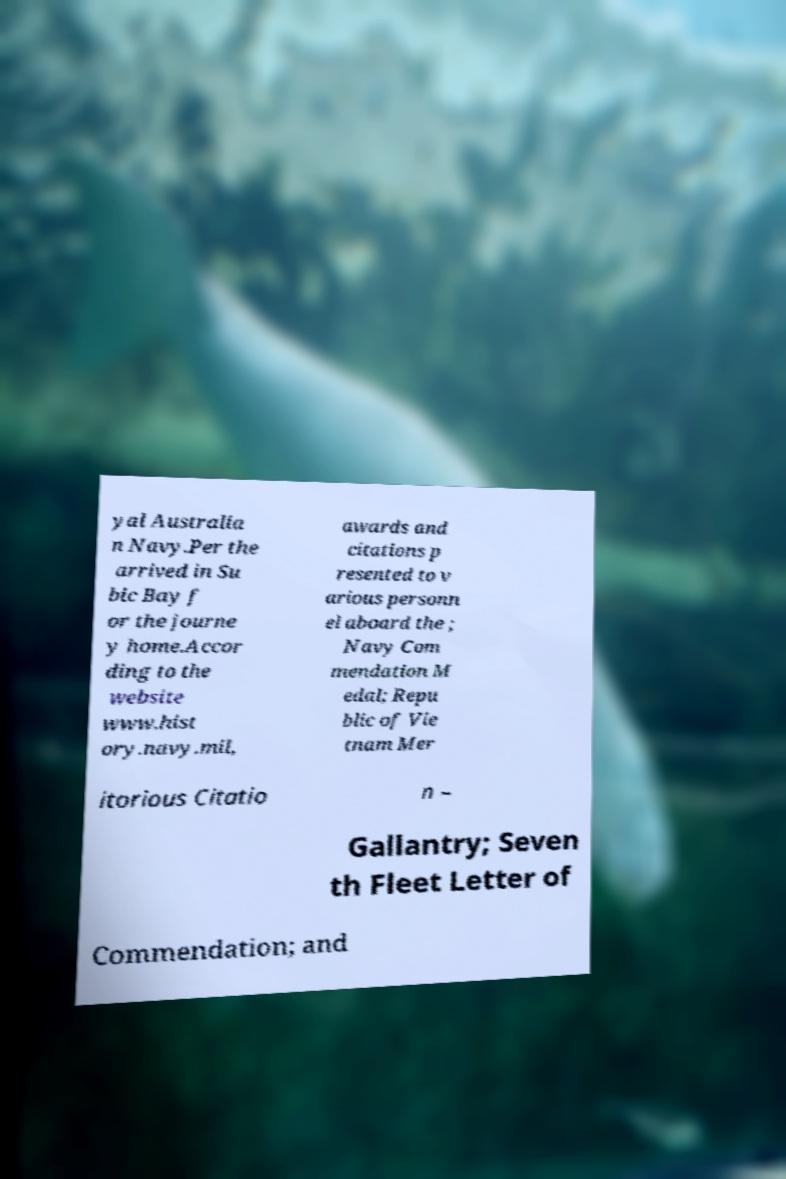I need the written content from this picture converted into text. Can you do that? yal Australia n Navy.Per the arrived in Su bic Bay f or the journe y home.Accor ding to the website www.hist ory.navy.mil, awards and citations p resented to v arious personn el aboard the ; Navy Com mendation M edal; Repu blic of Vie tnam Mer itorious Citatio n – Gallantry; Seven th Fleet Letter of Commendation; and 